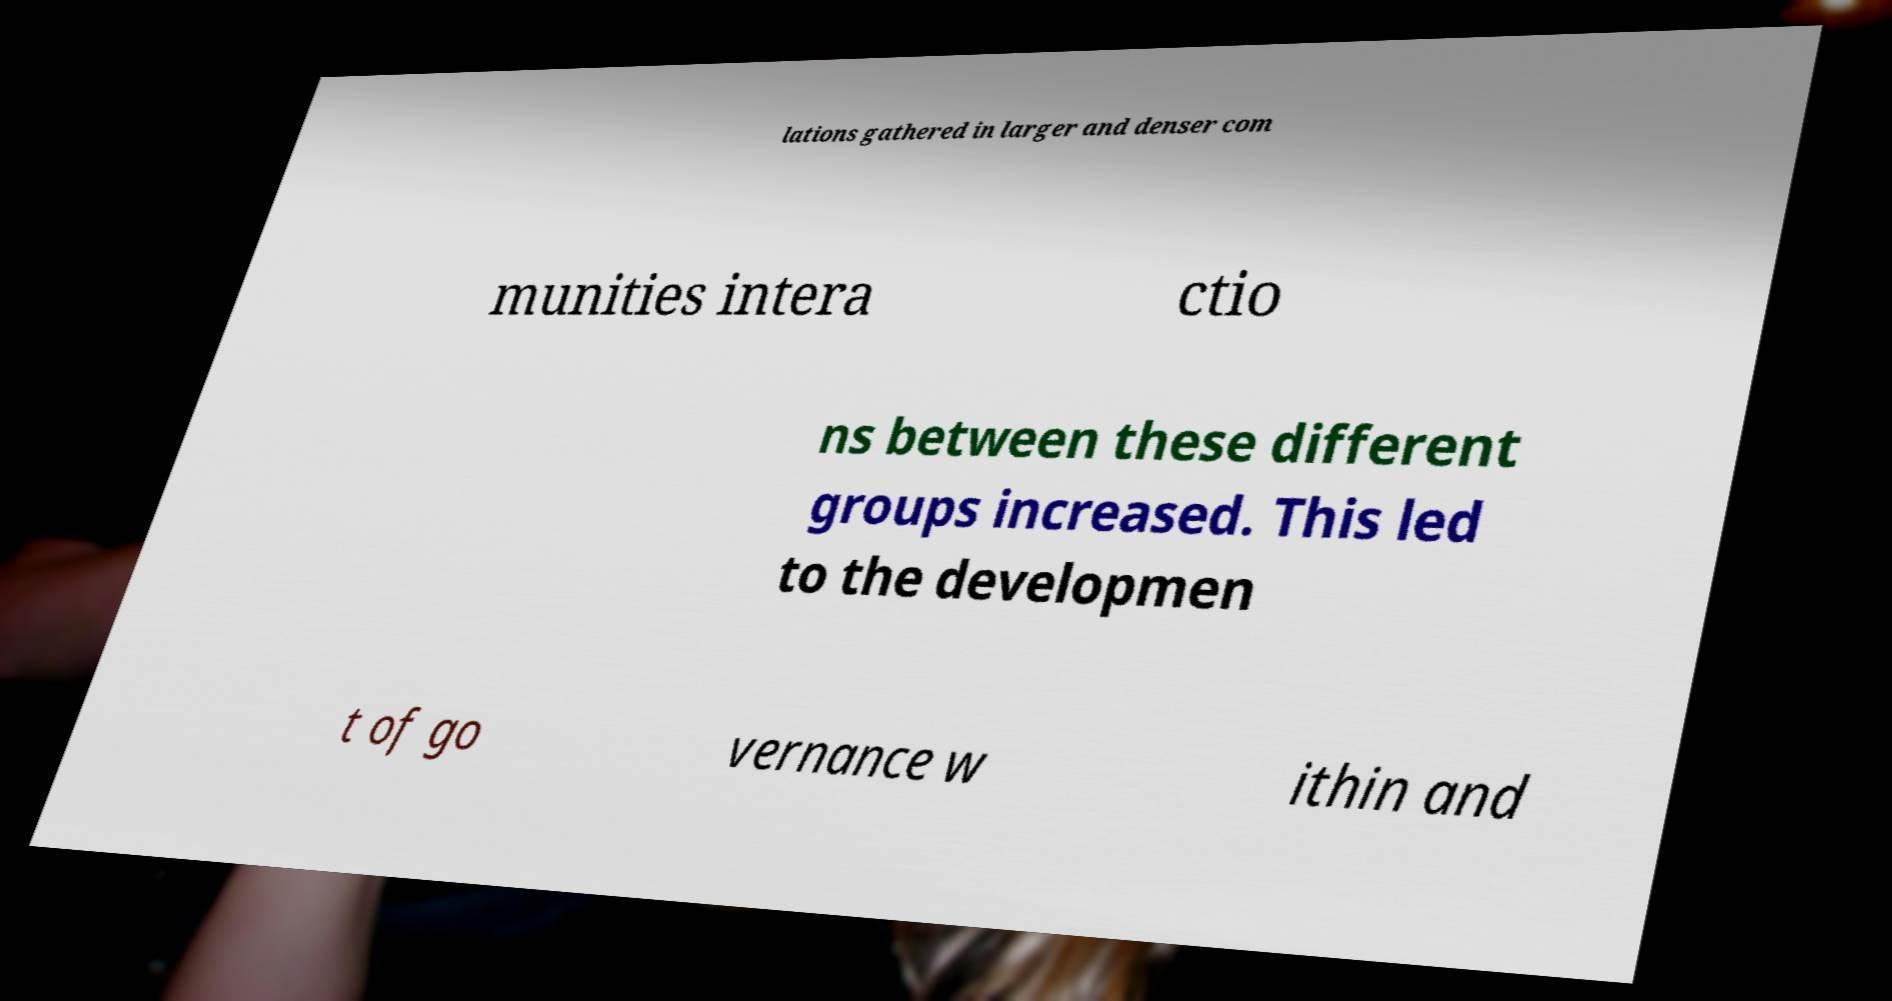Could you extract and type out the text from this image? lations gathered in larger and denser com munities intera ctio ns between these different groups increased. This led to the developmen t of go vernance w ithin and 